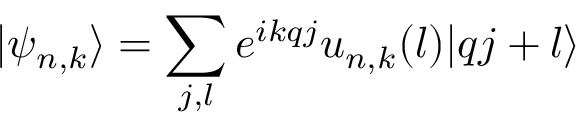<formula> <loc_0><loc_0><loc_500><loc_500>| { \psi _ { n , k } } \rangle = \sum _ { j , l } { { e ^ { i k q j } } { u _ { n , k } ( l ) } | q j + l \rangle }</formula> 